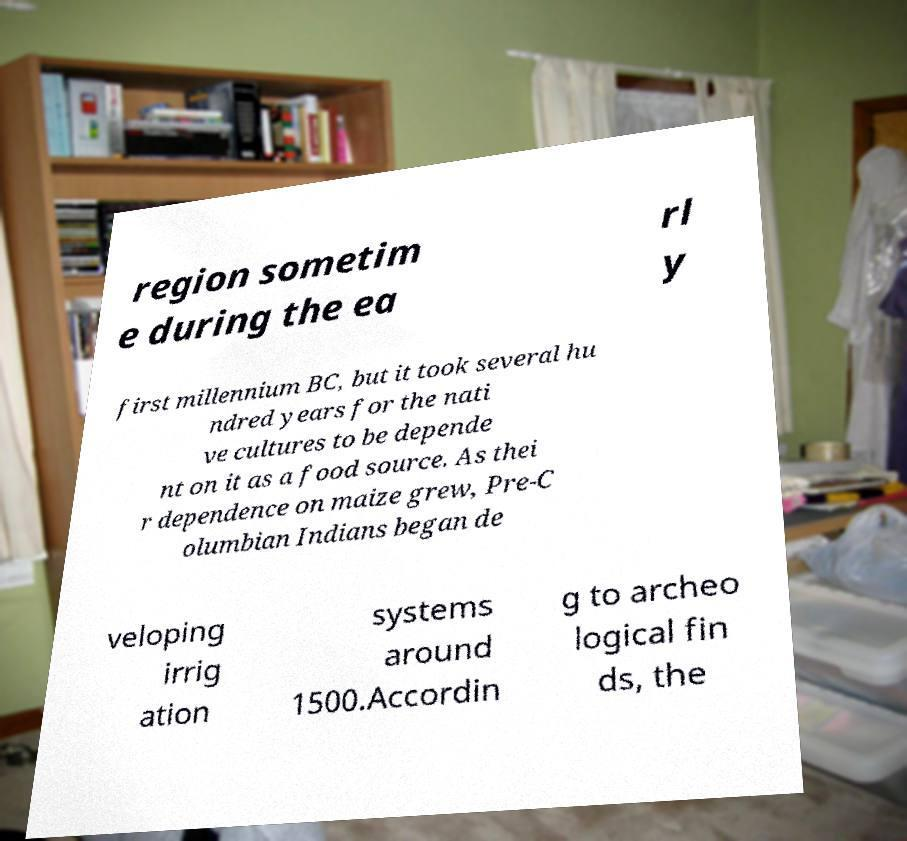I need the written content from this picture converted into text. Can you do that? region sometim e during the ea rl y first millennium BC, but it took several hu ndred years for the nati ve cultures to be depende nt on it as a food source. As thei r dependence on maize grew, Pre-C olumbian Indians began de veloping irrig ation systems around 1500.Accordin g to archeo logical fin ds, the 